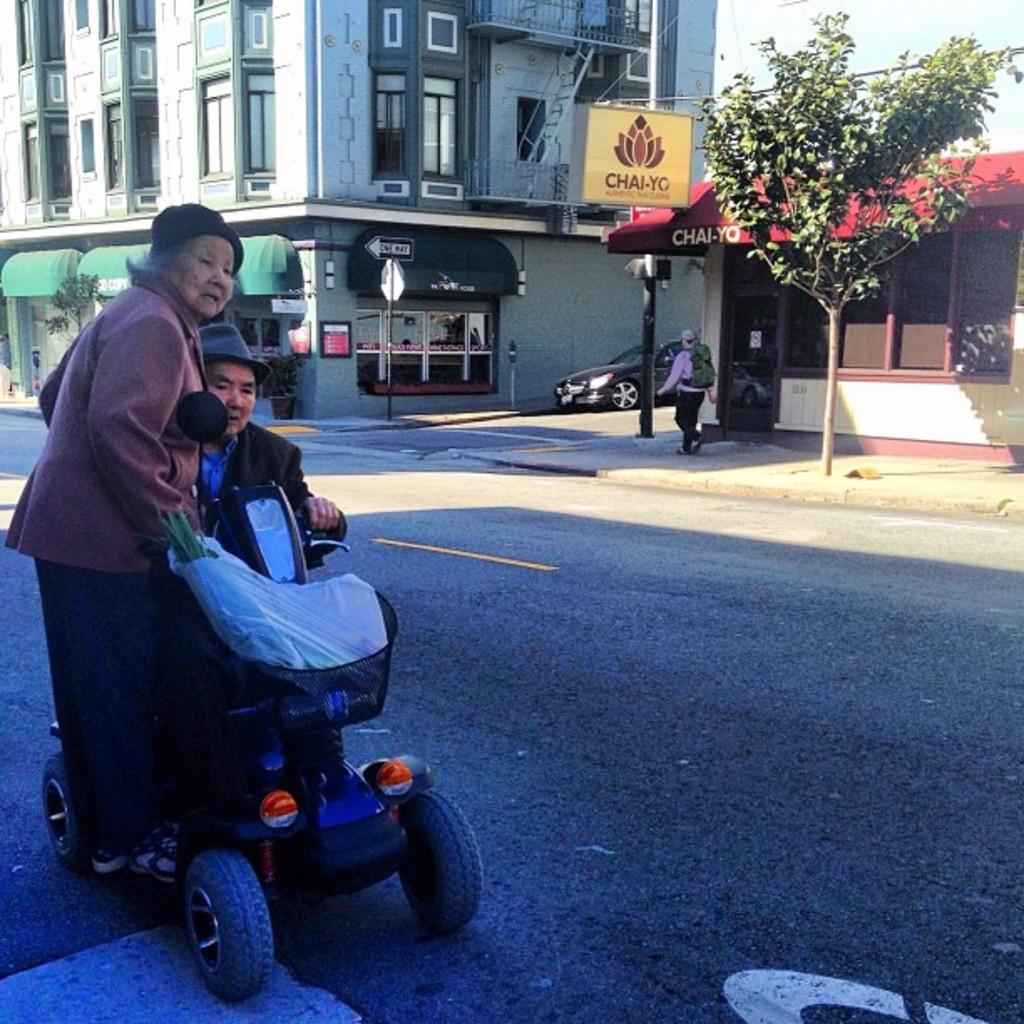How would you summarize this image in a sentence or two? In this image on the left, there is a man, he wears a suit and hat, he is driving a vehicle on that there is a woman, she wears a suit, trouser and shoes. On the right there is a man, he is walking. At the bottom there is a road. In the background there are buildings, houses, trees, sign boards, poles, car. 